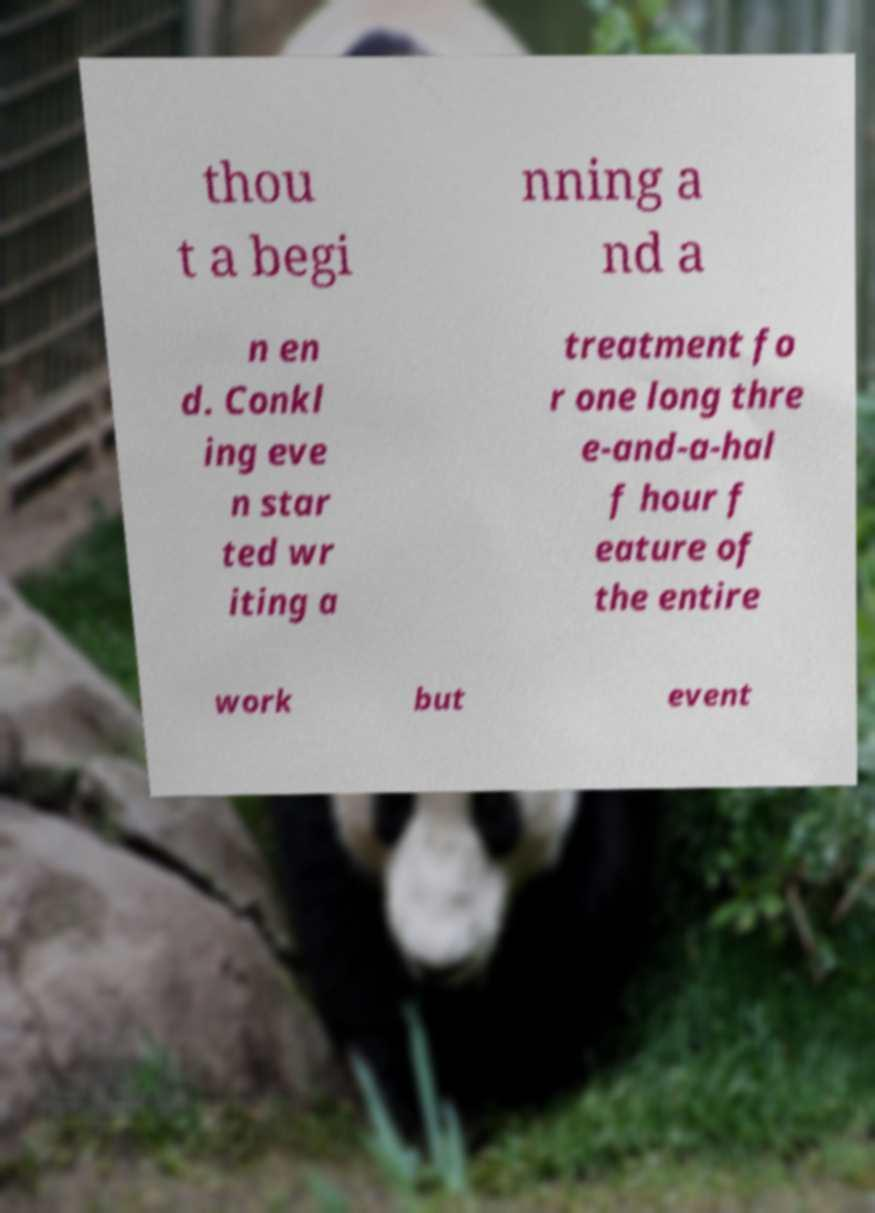Please identify and transcribe the text found in this image. thou t a begi nning a nd a n en d. Conkl ing eve n star ted wr iting a treatment fo r one long thre e-and-a-hal f hour f eature of the entire work but event 